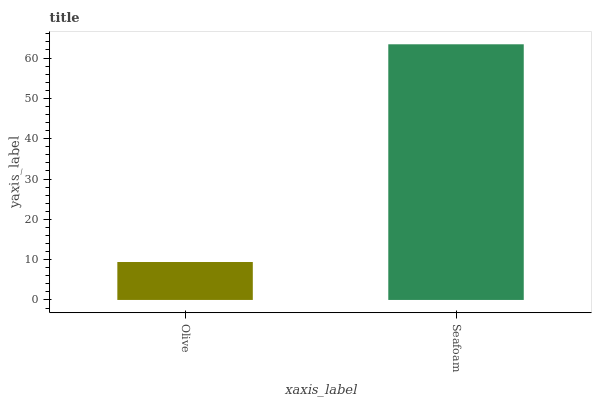Is Olive the minimum?
Answer yes or no. Yes. Is Seafoam the maximum?
Answer yes or no. Yes. Is Seafoam the minimum?
Answer yes or no. No. Is Seafoam greater than Olive?
Answer yes or no. Yes. Is Olive less than Seafoam?
Answer yes or no. Yes. Is Olive greater than Seafoam?
Answer yes or no. No. Is Seafoam less than Olive?
Answer yes or no. No. Is Seafoam the high median?
Answer yes or no. Yes. Is Olive the low median?
Answer yes or no. Yes. Is Olive the high median?
Answer yes or no. No. Is Seafoam the low median?
Answer yes or no. No. 